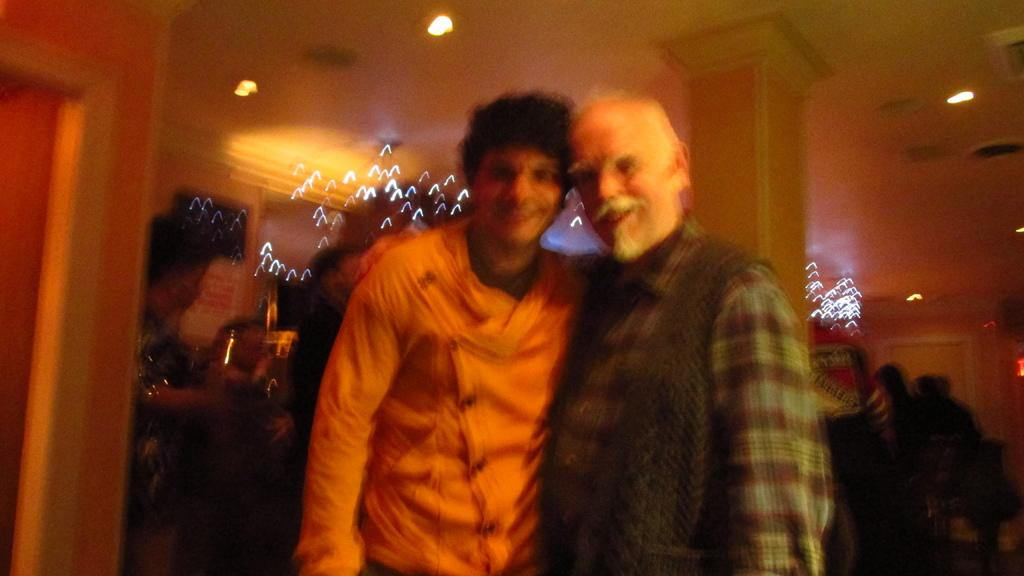How many people are standing and smiling in the image? There are two persons standing and smiling in the image. Are there any other people visible in the image? Yes, there are a few people behind the two persons. What architectural features can be seen in the image? There are doors and a pillar visible in the image. What is the lighting condition in the image? There are lights visible at the top of the image. What type of selection or list is being discussed by the people in the image? There is no indication in the image that the people are discussing a selection or list. Is there any evidence of a fight or conflict in the image? No, the image shows people standing and smiling, with no signs of conflict or a fight. 